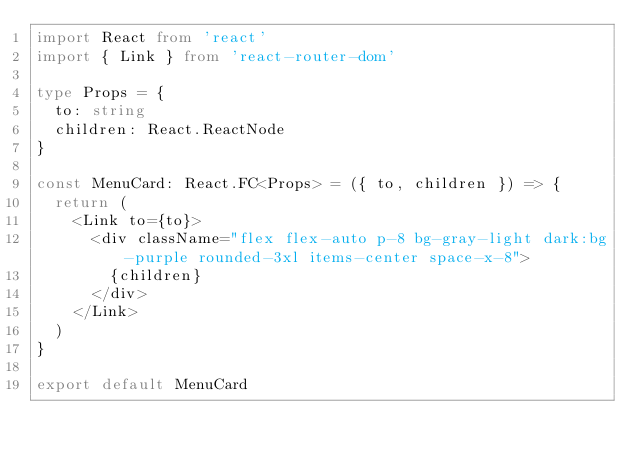Convert code to text. <code><loc_0><loc_0><loc_500><loc_500><_TypeScript_>import React from 'react'
import { Link } from 'react-router-dom'

type Props = {
  to: string
  children: React.ReactNode
}

const MenuCard: React.FC<Props> = ({ to, children }) => {
  return (
    <Link to={to}>
      <div className="flex flex-auto p-8 bg-gray-light dark:bg-purple rounded-3xl items-center space-x-8">
        {children}
      </div>
    </Link>
  )
}

export default MenuCard
</code> 